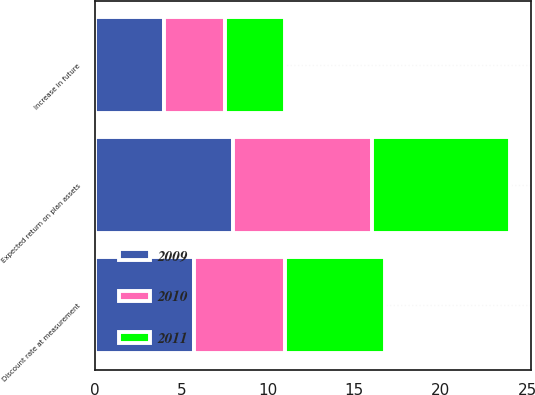Convert chart. <chart><loc_0><loc_0><loc_500><loc_500><stacked_bar_chart><ecel><fcel>Discount rate at measurement<fcel>Expected return on plan assets<fcel>Increase in future<nl><fcel>2010<fcel>5.25<fcel>8<fcel>3.5<nl><fcel>2011<fcel>5.75<fcel>8<fcel>3.5<nl><fcel>2009<fcel>5.75<fcel>8<fcel>4<nl></chart> 